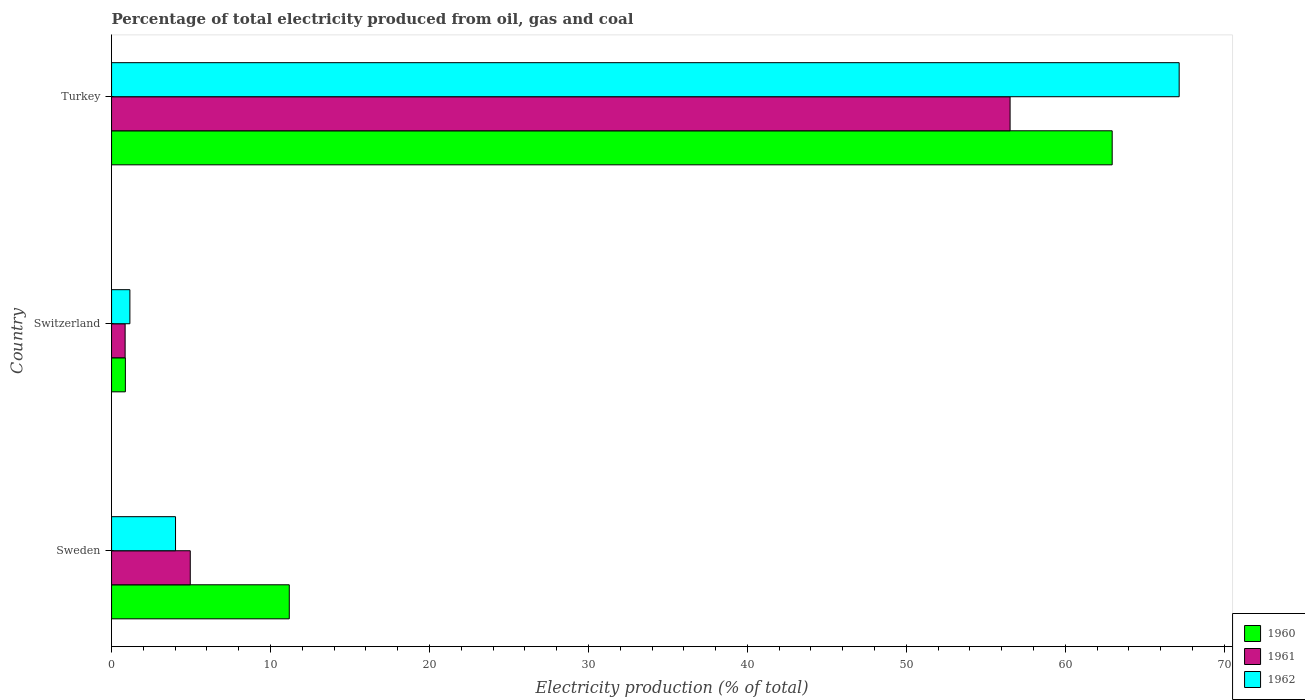Are the number of bars per tick equal to the number of legend labels?
Give a very brief answer. Yes. Are the number of bars on each tick of the Y-axis equal?
Keep it short and to the point. Yes. How many bars are there on the 1st tick from the top?
Provide a short and direct response. 3. How many bars are there on the 2nd tick from the bottom?
Offer a very short reply. 3. What is the label of the 1st group of bars from the top?
Provide a short and direct response. Turkey. In how many cases, is the number of bars for a given country not equal to the number of legend labels?
Offer a terse response. 0. What is the electricity production in in 1962 in Switzerland?
Your answer should be compact. 1.15. Across all countries, what is the maximum electricity production in in 1960?
Offer a terse response. 62.95. Across all countries, what is the minimum electricity production in in 1962?
Your answer should be compact. 1.15. In which country was the electricity production in in 1962 maximum?
Provide a short and direct response. Turkey. In which country was the electricity production in in 1961 minimum?
Offer a very short reply. Switzerland. What is the total electricity production in in 1961 in the graph?
Offer a very short reply. 62.33. What is the difference between the electricity production in in 1962 in Sweden and that in Turkey?
Keep it short and to the point. -63.14. What is the difference between the electricity production in in 1960 in Turkey and the electricity production in in 1962 in Switzerland?
Keep it short and to the point. 61.8. What is the average electricity production in in 1960 per country?
Provide a succinct answer. 25. What is the difference between the electricity production in in 1960 and electricity production in in 1961 in Switzerland?
Your response must be concise. 0.02. What is the ratio of the electricity production in in 1961 in Sweden to that in Switzerland?
Your response must be concise. 5.8. Is the electricity production in in 1961 in Switzerland less than that in Turkey?
Your answer should be compact. Yes. Is the difference between the electricity production in in 1960 in Sweden and Turkey greater than the difference between the electricity production in in 1961 in Sweden and Turkey?
Ensure brevity in your answer.  No. What is the difference between the highest and the second highest electricity production in in 1960?
Your response must be concise. 51.77. What is the difference between the highest and the lowest electricity production in in 1961?
Provide a short and direct response. 55.67. In how many countries, is the electricity production in in 1960 greater than the average electricity production in in 1960 taken over all countries?
Your answer should be compact. 1. Is the sum of the electricity production in in 1961 in Sweden and Switzerland greater than the maximum electricity production in in 1960 across all countries?
Provide a succinct answer. No. What does the 1st bar from the top in Switzerland represents?
Your answer should be compact. 1962. Is it the case that in every country, the sum of the electricity production in in 1961 and electricity production in in 1962 is greater than the electricity production in in 1960?
Ensure brevity in your answer.  No. How many bars are there?
Make the answer very short. 9. Does the graph contain grids?
Offer a terse response. No. Where does the legend appear in the graph?
Give a very brief answer. Bottom right. How many legend labels are there?
Give a very brief answer. 3. How are the legend labels stacked?
Provide a succinct answer. Vertical. What is the title of the graph?
Ensure brevity in your answer.  Percentage of total electricity produced from oil, gas and coal. Does "1975" appear as one of the legend labels in the graph?
Offer a terse response. No. What is the label or title of the X-axis?
Give a very brief answer. Electricity production (% of total). What is the label or title of the Y-axis?
Keep it short and to the point. Country. What is the Electricity production (% of total) in 1960 in Sweden?
Your answer should be very brief. 11.18. What is the Electricity production (% of total) in 1961 in Sweden?
Your answer should be very brief. 4.95. What is the Electricity production (% of total) in 1962 in Sweden?
Make the answer very short. 4.02. What is the Electricity production (% of total) of 1960 in Switzerland?
Ensure brevity in your answer.  0.87. What is the Electricity production (% of total) in 1961 in Switzerland?
Offer a very short reply. 0.85. What is the Electricity production (% of total) of 1962 in Switzerland?
Make the answer very short. 1.15. What is the Electricity production (% of total) of 1960 in Turkey?
Give a very brief answer. 62.95. What is the Electricity production (% of total) of 1961 in Turkey?
Provide a short and direct response. 56.53. What is the Electricity production (% of total) in 1962 in Turkey?
Give a very brief answer. 67.16. Across all countries, what is the maximum Electricity production (% of total) in 1960?
Your answer should be very brief. 62.95. Across all countries, what is the maximum Electricity production (% of total) in 1961?
Offer a very short reply. 56.53. Across all countries, what is the maximum Electricity production (% of total) of 1962?
Your answer should be very brief. 67.16. Across all countries, what is the minimum Electricity production (% of total) in 1960?
Provide a succinct answer. 0.87. Across all countries, what is the minimum Electricity production (% of total) of 1961?
Keep it short and to the point. 0.85. Across all countries, what is the minimum Electricity production (% of total) in 1962?
Offer a terse response. 1.15. What is the total Electricity production (% of total) in 1960 in the graph?
Provide a succinct answer. 75. What is the total Electricity production (% of total) in 1961 in the graph?
Your answer should be very brief. 62.33. What is the total Electricity production (% of total) in 1962 in the graph?
Provide a short and direct response. 72.34. What is the difference between the Electricity production (% of total) of 1960 in Sweden and that in Switzerland?
Your answer should be very brief. 10.31. What is the difference between the Electricity production (% of total) in 1961 in Sweden and that in Switzerland?
Your answer should be compact. 4.1. What is the difference between the Electricity production (% of total) of 1962 in Sweden and that in Switzerland?
Your answer should be very brief. 2.87. What is the difference between the Electricity production (% of total) of 1960 in Sweden and that in Turkey?
Provide a short and direct response. -51.77. What is the difference between the Electricity production (% of total) in 1961 in Sweden and that in Turkey?
Offer a very short reply. -51.57. What is the difference between the Electricity production (% of total) of 1962 in Sweden and that in Turkey?
Give a very brief answer. -63.14. What is the difference between the Electricity production (% of total) of 1960 in Switzerland and that in Turkey?
Your answer should be compact. -62.08. What is the difference between the Electricity production (% of total) of 1961 in Switzerland and that in Turkey?
Offer a very short reply. -55.67. What is the difference between the Electricity production (% of total) in 1962 in Switzerland and that in Turkey?
Provide a short and direct response. -66.01. What is the difference between the Electricity production (% of total) in 1960 in Sweden and the Electricity production (% of total) in 1961 in Switzerland?
Keep it short and to the point. 10.33. What is the difference between the Electricity production (% of total) of 1960 in Sweden and the Electricity production (% of total) of 1962 in Switzerland?
Your answer should be very brief. 10.03. What is the difference between the Electricity production (% of total) of 1961 in Sweden and the Electricity production (% of total) of 1962 in Switzerland?
Your answer should be compact. 3.8. What is the difference between the Electricity production (% of total) of 1960 in Sweden and the Electricity production (% of total) of 1961 in Turkey?
Offer a terse response. -45.35. What is the difference between the Electricity production (% of total) of 1960 in Sweden and the Electricity production (% of total) of 1962 in Turkey?
Provide a succinct answer. -55.98. What is the difference between the Electricity production (% of total) in 1961 in Sweden and the Electricity production (% of total) in 1962 in Turkey?
Provide a succinct answer. -62.21. What is the difference between the Electricity production (% of total) of 1960 in Switzerland and the Electricity production (% of total) of 1961 in Turkey?
Make the answer very short. -55.66. What is the difference between the Electricity production (% of total) in 1960 in Switzerland and the Electricity production (% of total) in 1962 in Turkey?
Your answer should be compact. -66.29. What is the difference between the Electricity production (% of total) of 1961 in Switzerland and the Electricity production (% of total) of 1962 in Turkey?
Give a very brief answer. -66.31. What is the average Electricity production (% of total) of 1960 per country?
Offer a very short reply. 25. What is the average Electricity production (% of total) in 1961 per country?
Keep it short and to the point. 20.78. What is the average Electricity production (% of total) of 1962 per country?
Offer a very short reply. 24.11. What is the difference between the Electricity production (% of total) of 1960 and Electricity production (% of total) of 1961 in Sweden?
Give a very brief answer. 6.23. What is the difference between the Electricity production (% of total) of 1960 and Electricity production (% of total) of 1962 in Sweden?
Offer a very short reply. 7.16. What is the difference between the Electricity production (% of total) in 1961 and Electricity production (% of total) in 1962 in Sweden?
Keep it short and to the point. 0.93. What is the difference between the Electricity production (% of total) in 1960 and Electricity production (% of total) in 1961 in Switzerland?
Make the answer very short. 0.02. What is the difference between the Electricity production (% of total) of 1960 and Electricity production (% of total) of 1962 in Switzerland?
Your answer should be very brief. -0.28. What is the difference between the Electricity production (% of total) of 1961 and Electricity production (% of total) of 1962 in Switzerland?
Provide a short and direct response. -0.3. What is the difference between the Electricity production (% of total) in 1960 and Electricity production (% of total) in 1961 in Turkey?
Your response must be concise. 6.42. What is the difference between the Electricity production (% of total) of 1960 and Electricity production (% of total) of 1962 in Turkey?
Your answer should be very brief. -4.21. What is the difference between the Electricity production (% of total) in 1961 and Electricity production (% of total) in 1962 in Turkey?
Your answer should be very brief. -10.64. What is the ratio of the Electricity production (% of total) in 1960 in Sweden to that in Switzerland?
Offer a very short reply. 12.86. What is the ratio of the Electricity production (% of total) in 1961 in Sweden to that in Switzerland?
Ensure brevity in your answer.  5.8. What is the ratio of the Electricity production (% of total) of 1962 in Sweden to that in Switzerland?
Ensure brevity in your answer.  3.49. What is the ratio of the Electricity production (% of total) of 1960 in Sweden to that in Turkey?
Your response must be concise. 0.18. What is the ratio of the Electricity production (% of total) of 1961 in Sweden to that in Turkey?
Your answer should be compact. 0.09. What is the ratio of the Electricity production (% of total) in 1962 in Sweden to that in Turkey?
Give a very brief answer. 0.06. What is the ratio of the Electricity production (% of total) in 1960 in Switzerland to that in Turkey?
Provide a succinct answer. 0.01. What is the ratio of the Electricity production (% of total) of 1961 in Switzerland to that in Turkey?
Your response must be concise. 0.02. What is the ratio of the Electricity production (% of total) in 1962 in Switzerland to that in Turkey?
Keep it short and to the point. 0.02. What is the difference between the highest and the second highest Electricity production (% of total) in 1960?
Give a very brief answer. 51.77. What is the difference between the highest and the second highest Electricity production (% of total) in 1961?
Keep it short and to the point. 51.57. What is the difference between the highest and the second highest Electricity production (% of total) of 1962?
Provide a succinct answer. 63.14. What is the difference between the highest and the lowest Electricity production (% of total) of 1960?
Keep it short and to the point. 62.08. What is the difference between the highest and the lowest Electricity production (% of total) of 1961?
Your response must be concise. 55.67. What is the difference between the highest and the lowest Electricity production (% of total) in 1962?
Your answer should be very brief. 66.01. 